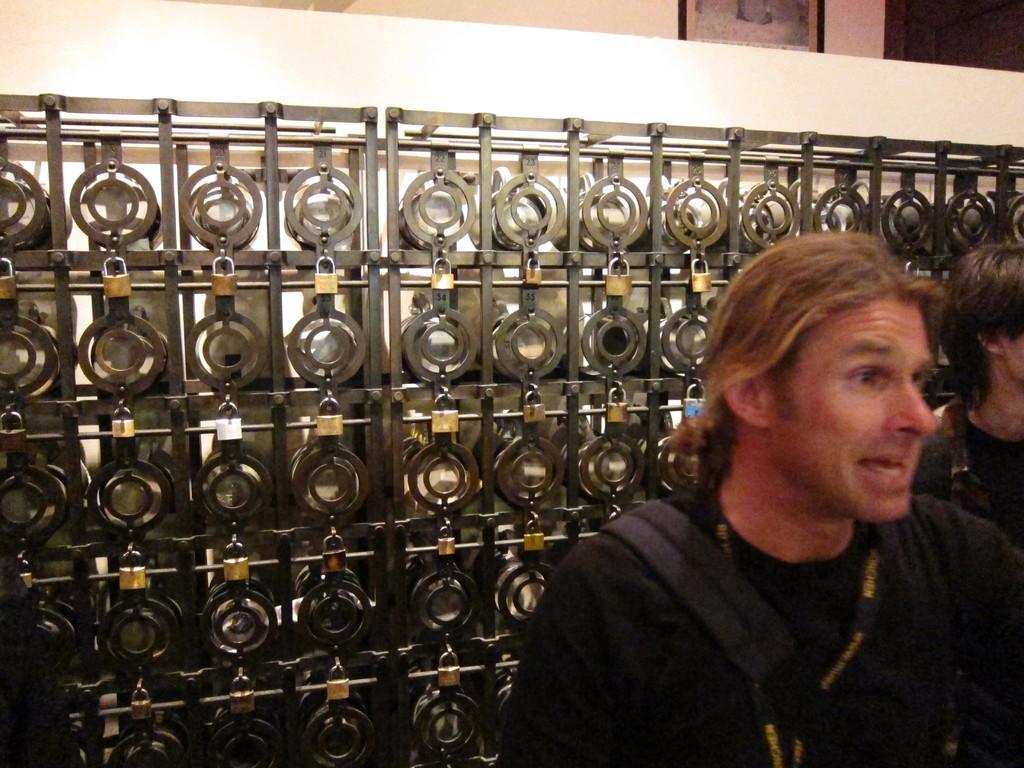Could you give a brief overview of what you see in this image? In this image there are two persons, there is a person truncated towards the right of the image, there is an object behind the person, there is an object truncated towards the left of the image, there is a wall, there is a photo frame truncated, there is an object truncated towards the right of the image. 